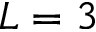<formula> <loc_0><loc_0><loc_500><loc_500>L = 3</formula> 